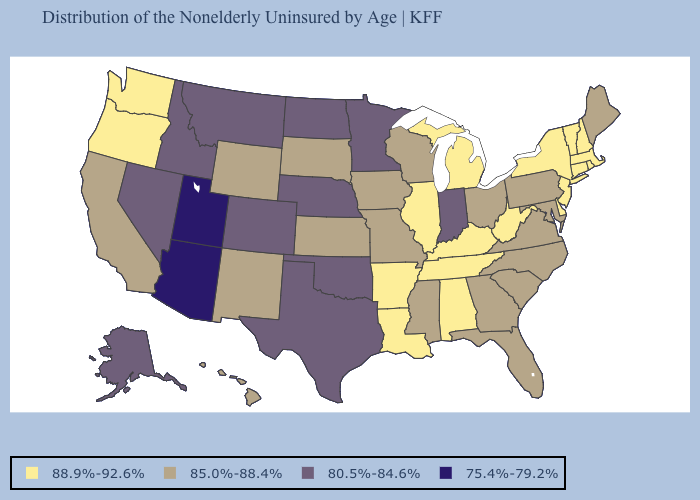Name the states that have a value in the range 88.9%-92.6%?
Write a very short answer. Alabama, Arkansas, Connecticut, Delaware, Illinois, Kentucky, Louisiana, Massachusetts, Michigan, New Hampshire, New Jersey, New York, Oregon, Rhode Island, Tennessee, Vermont, Washington, West Virginia. Which states hav the highest value in the MidWest?
Quick response, please. Illinois, Michigan. Which states have the highest value in the USA?
Quick response, please. Alabama, Arkansas, Connecticut, Delaware, Illinois, Kentucky, Louisiana, Massachusetts, Michigan, New Hampshire, New Jersey, New York, Oregon, Rhode Island, Tennessee, Vermont, Washington, West Virginia. What is the value of Alaska?
Concise answer only. 80.5%-84.6%. Does Arizona have the lowest value in the USA?
Short answer required. Yes. What is the value of Alaska?
Concise answer only. 80.5%-84.6%. Which states have the highest value in the USA?
Give a very brief answer. Alabama, Arkansas, Connecticut, Delaware, Illinois, Kentucky, Louisiana, Massachusetts, Michigan, New Hampshire, New Jersey, New York, Oregon, Rhode Island, Tennessee, Vermont, Washington, West Virginia. Among the states that border Ohio , does Indiana have the lowest value?
Keep it brief. Yes. Name the states that have a value in the range 85.0%-88.4%?
Keep it brief. California, Florida, Georgia, Hawaii, Iowa, Kansas, Maine, Maryland, Mississippi, Missouri, New Mexico, North Carolina, Ohio, Pennsylvania, South Carolina, South Dakota, Virginia, Wisconsin, Wyoming. What is the value of Nevada?
Answer briefly. 80.5%-84.6%. Does Ohio have the lowest value in the MidWest?
Concise answer only. No. Name the states that have a value in the range 85.0%-88.4%?
Concise answer only. California, Florida, Georgia, Hawaii, Iowa, Kansas, Maine, Maryland, Mississippi, Missouri, New Mexico, North Carolina, Ohio, Pennsylvania, South Carolina, South Dakota, Virginia, Wisconsin, Wyoming. Is the legend a continuous bar?
Quick response, please. No. What is the highest value in the USA?
Concise answer only. 88.9%-92.6%. Does Oklahoma have the lowest value in the South?
Concise answer only. Yes. 